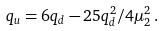Convert formula to latex. <formula><loc_0><loc_0><loc_500><loc_500>q _ { u } = 6 q _ { d } - 2 5 q _ { d } ^ { 2 } / 4 \mu _ { 2 } ^ { 2 } \, .</formula> 